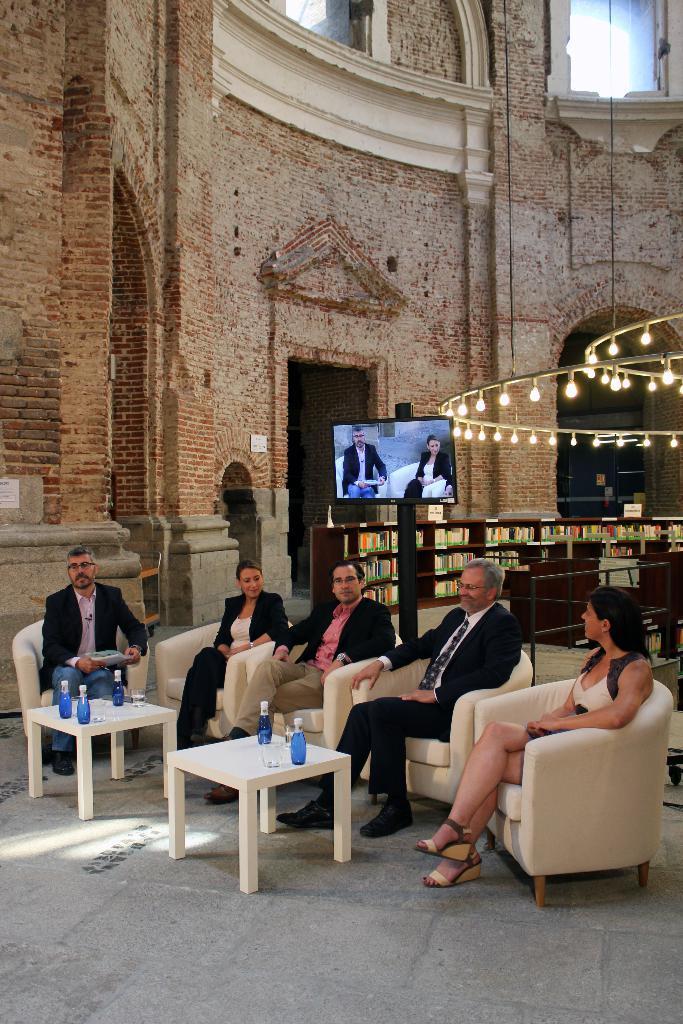Describe this image in one or two sentences. This picture shows a big building and a television and new lights, And 5 people seated on the chairs,three are men and two are woman. in front of them there are two tables on the table we can see water bottles 